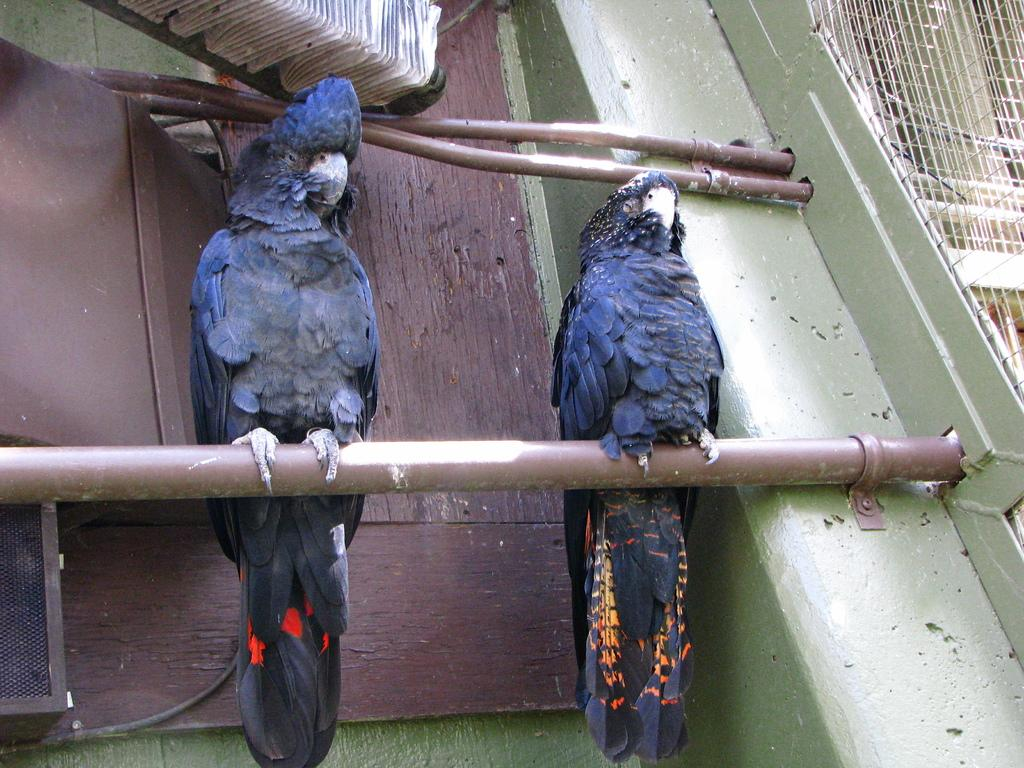What animals can be seen in the image? There are two birds on a pipe in the image. What type of structure is visible in the background? There are small pipes visible in the background of the image. What material is the board in the background made of? The board in the background is made of wood. What can be seen on the right side of the image? There is a grill on the right side of the image. What type of sponge is floating in the water near the dock in the image? There is no dock or water present in the image, and therefore no sponge can be observed. 